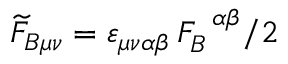Convert formula to latex. <formula><loc_0><loc_0><loc_500><loc_500>\widetilde { F } _ { B \mu \nu } = \varepsilon _ { \mu \nu \alpha \beta } \, F _ { B } ^ { \, \alpha \beta } / 2</formula> 